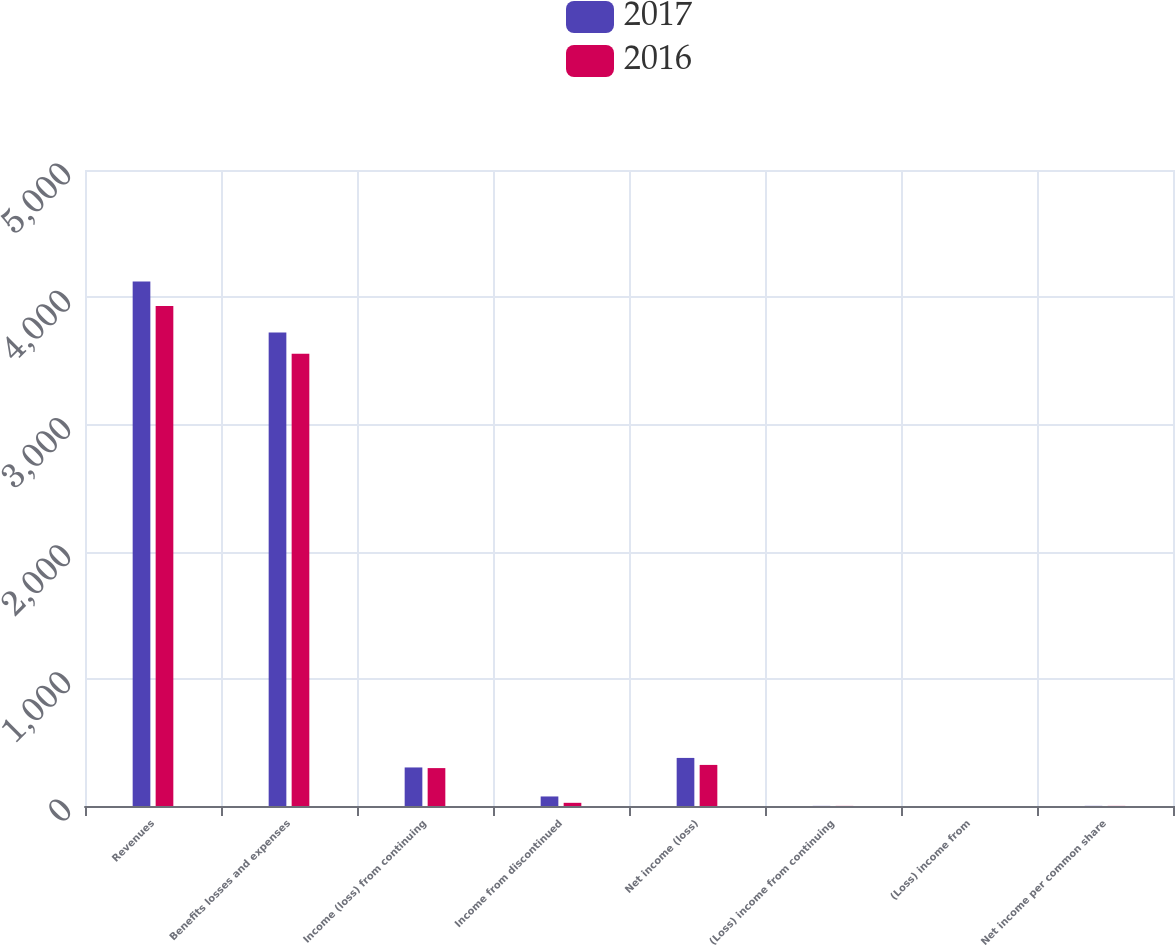Convert chart to OTSL. <chart><loc_0><loc_0><loc_500><loc_500><stacked_bar_chart><ecel><fcel>Revenues<fcel>Benefits losses and expenses<fcel>Income (loss) from continuing<fcel>Income from discontinued<fcel>Net income (loss)<fcel>(Loss) income from continuing<fcel>(Loss) income from<fcel>Net income per common share<nl><fcel>2017<fcel>4123<fcel>3722<fcel>303<fcel>75<fcel>378<fcel>0.82<fcel>0.2<fcel>1.02<nl><fcel>2016<fcel>3930<fcel>3556<fcel>298<fcel>25<fcel>323<fcel>0.75<fcel>0.06<fcel>0.81<nl></chart> 